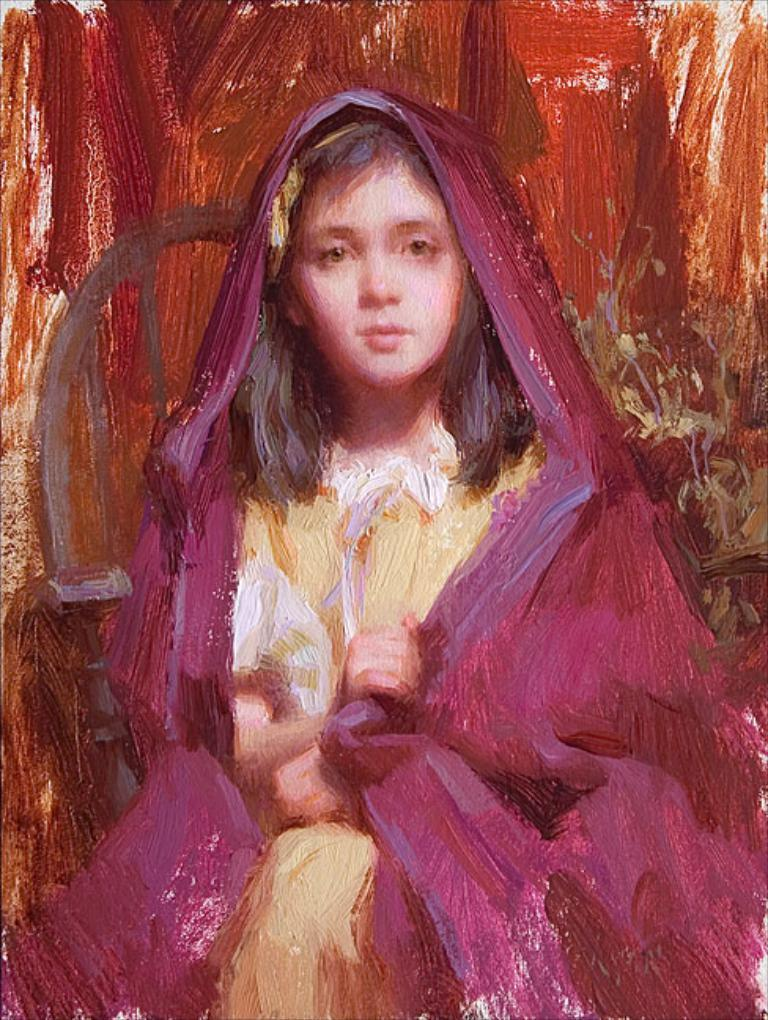What is the main subject of the image? There is a painting in the image. What does the painting depict? The painting depicts a sitting girl. How many boats are docked at the harbor in the image? There is no harbor or boats present in the image; it features a painting of a sitting girl. What is the relation between the girl in the painting and the person viewing the image? The relation between the girl in the painting and the person viewing the image cannot be determined from the image itself, as it is a static representation. 